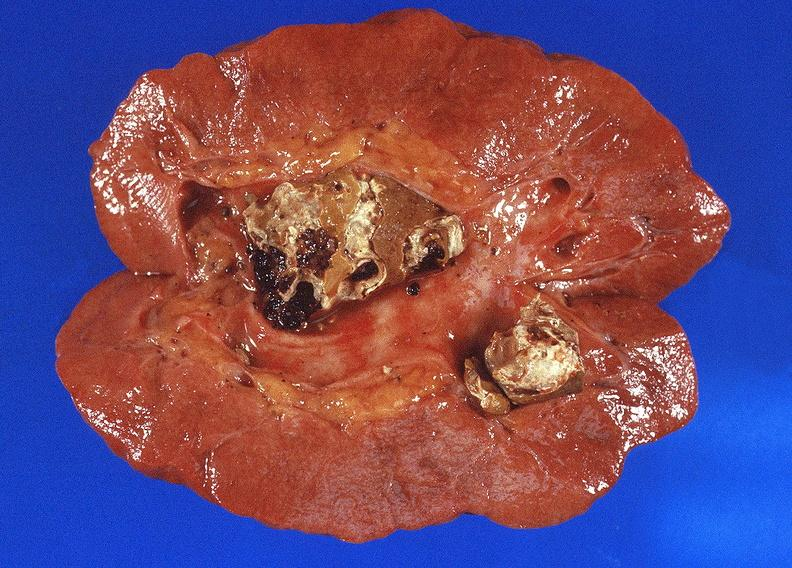does this image show staghorn calculi in renal pelvis, gout?
Answer the question using a single word or phrase. Yes 